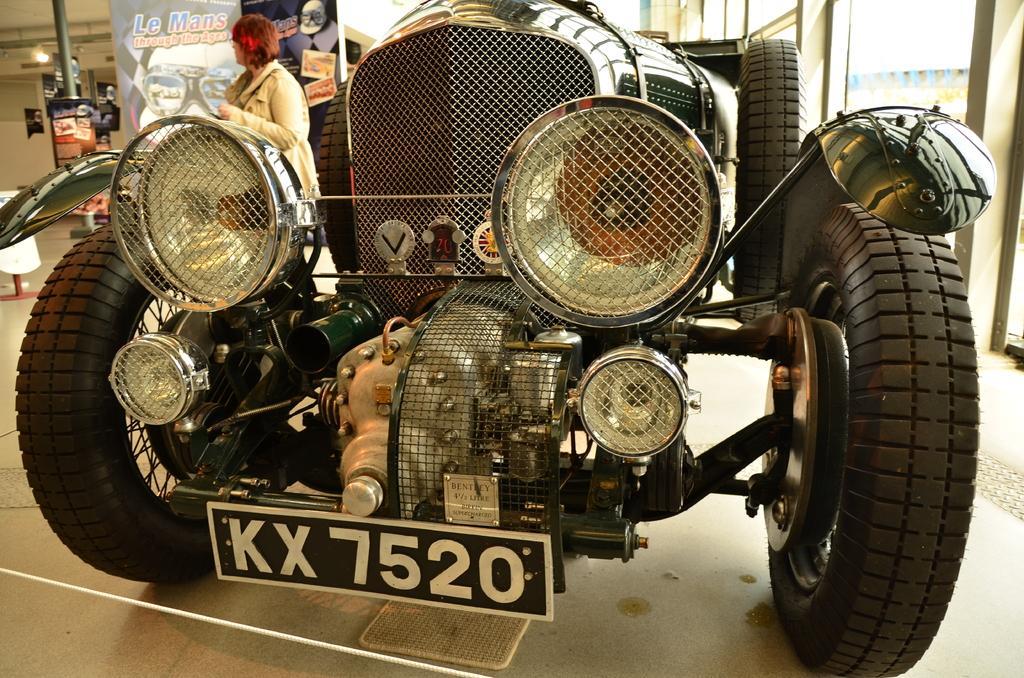Could you give a brief overview of what you see in this image? In this image I can see a vehicle and I can see a woman visible beside that vehicle and I can see a pole and light on the left side. 